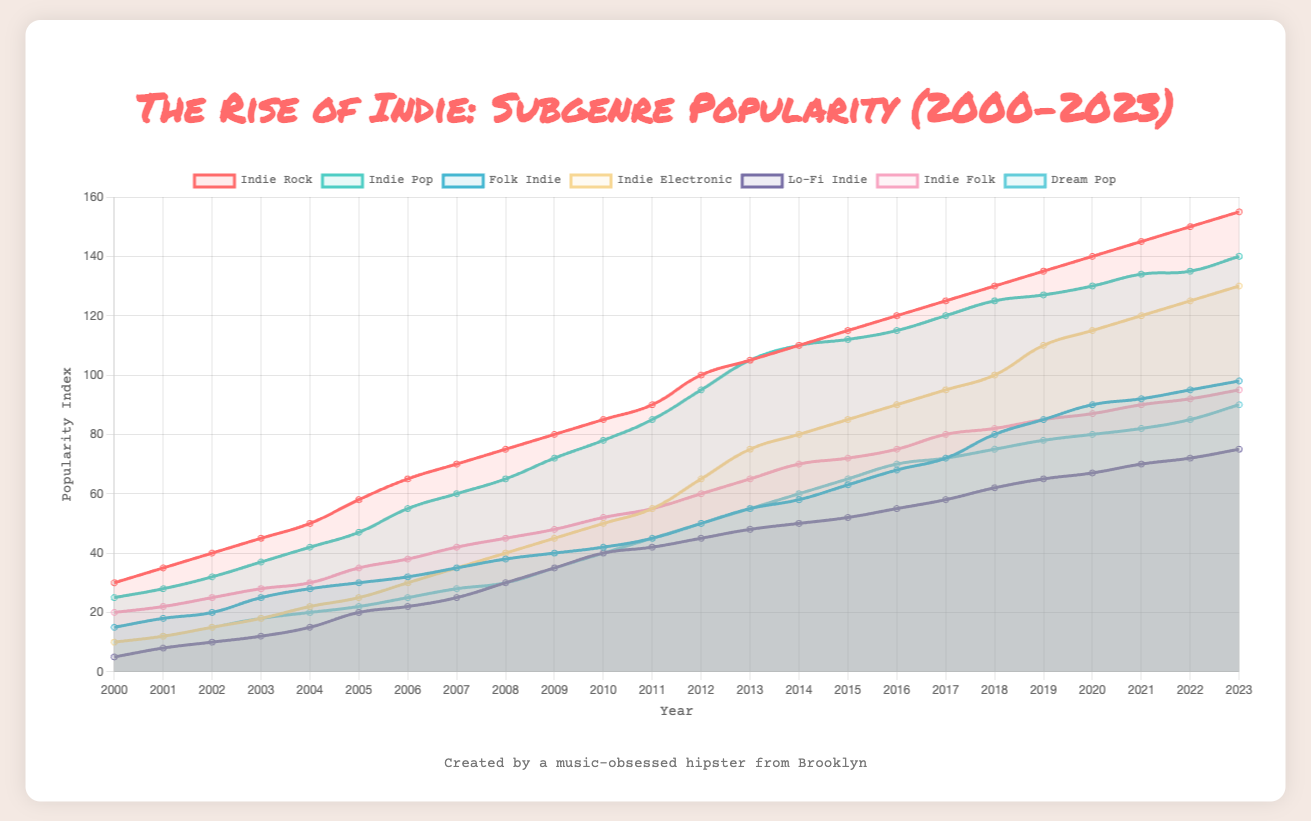What's the most popular subgenre in 2023? The data shows the popularity of each subgenre over the years. Looking at the popularity values for each subgenre in 2023, "Indie Rock" has the highest popularity index of 155.
Answer: Indie Rock Which subgenre saw the highest increase in popularity from 2010 to 2023? To determine the subgenre with the highest increase, subtract the 2010 value from the 2023 value for each subgenre. Indie Rock: 155 - 85 = 70, Indie Pop: 140 - 78 = 62, Folk Indie: 98 - 42 = 56, Indie Electronic: 130 - 50 = 80, Lo-Fi Indie: 75 - 40 = 35, Indie Folk: 95 - 52 = 43, Dream Pop: 90 - 40 = 50. Indie Electronic has the highest increase of 80.
Answer: Indie Electronic Which subgenre's popularity remained the most stable over the years from 2000 to 2023? The stability can be judged by measuring the range (difference between the maximum and minimum popularity). Indie Rock: 155 - 30 = 125, Indie Pop: 140 - 25 = 115, Folk Indie: 98 - 15 = 83, Indie Electronic: 130 - 10 = 120, Lo-Fi Indie: 75 - 5 = 70, Indie Folk: 95 - 20 = 75, Dream Pop: 90 - 10 = 80. Lo-Fi Indie has the smallest range of 70, indicating the most stable popularity.
Answer: Lo-Fi Indie From 2000 to 2023, in which year did "Dream Pop" see the biggest single-year increase in popularity? Check the differences year-on-year in the "Dream Pop" data. 2001: +2, 2002: +3, 2003: +3, 2004: +2, 2005: +2, 2006: +3, 2007: +3, 2008: +2, 2009: +5, 2010: +5, 2011: +5, 2012: +5, 2013: +5, 2014: +5, 2015: +5, 2016: +5, 2017: +2, 2018: +3, 2019: +3, 2020: +2, 2021: +2, 2022: +3, 2023: +5. The biggest increase of +5 occurred multiple times, starting in 2010.
Answer: 2010 In 2015, which subgenre had a lower popularity than "Folk Indie"? Compare the 2015 popularity values of all subgenres with that of "Folk Indie" in 2015 (63). Indie Rock: 115, Indie Pop: 112, Folk Indie: 63, Indie Electronic: 85, Lo-Fi Indie: 52, Indie Folk: 72, Dream Pop: 65. "Lo-Fi Indie" had a lower popularity than "Folk Indie".
Answer: Lo-Fi Indie What's the average popularity of "Indie Pop" from 2000 to 2010? Average is calculated by summing up the values from 2000 to 2010 and dividing by the number of years. (25 + 28 + 32 + 37 + 42 + 47 + 55 + 60 + 65 + 72 + 78) / 11 = 541 / 11 ≈ 49.18
Answer: 49.18 Which subgenre had the sharpest decline in popularity between two consecutive years? Check year-on-year differences for the sharpest negative change. Calculating changes for each subgenre: Indie Rock (none decrease), Indie Pop: (115 to 112 in 2016-2017: -3), Folk Indie (none decrease), Indie Electronic (none decrease), Lo-Fi Indie (none decrease), Indie Folk (none decrease), Dream Pop (none decrease). The sharpest decline is in Indie Pop from 2016 to 2017.
Answer: Indie Pop (2016-2017) Between "Indie Rock" and "Indie Electronic", which subgenre had a higher popularity in 2012? Compare 2012 popularity values for Indie Rock (100) and Indie Electronic (65). Indie Rock had a higher popularity in 2012.
Answer: Indie Rock 